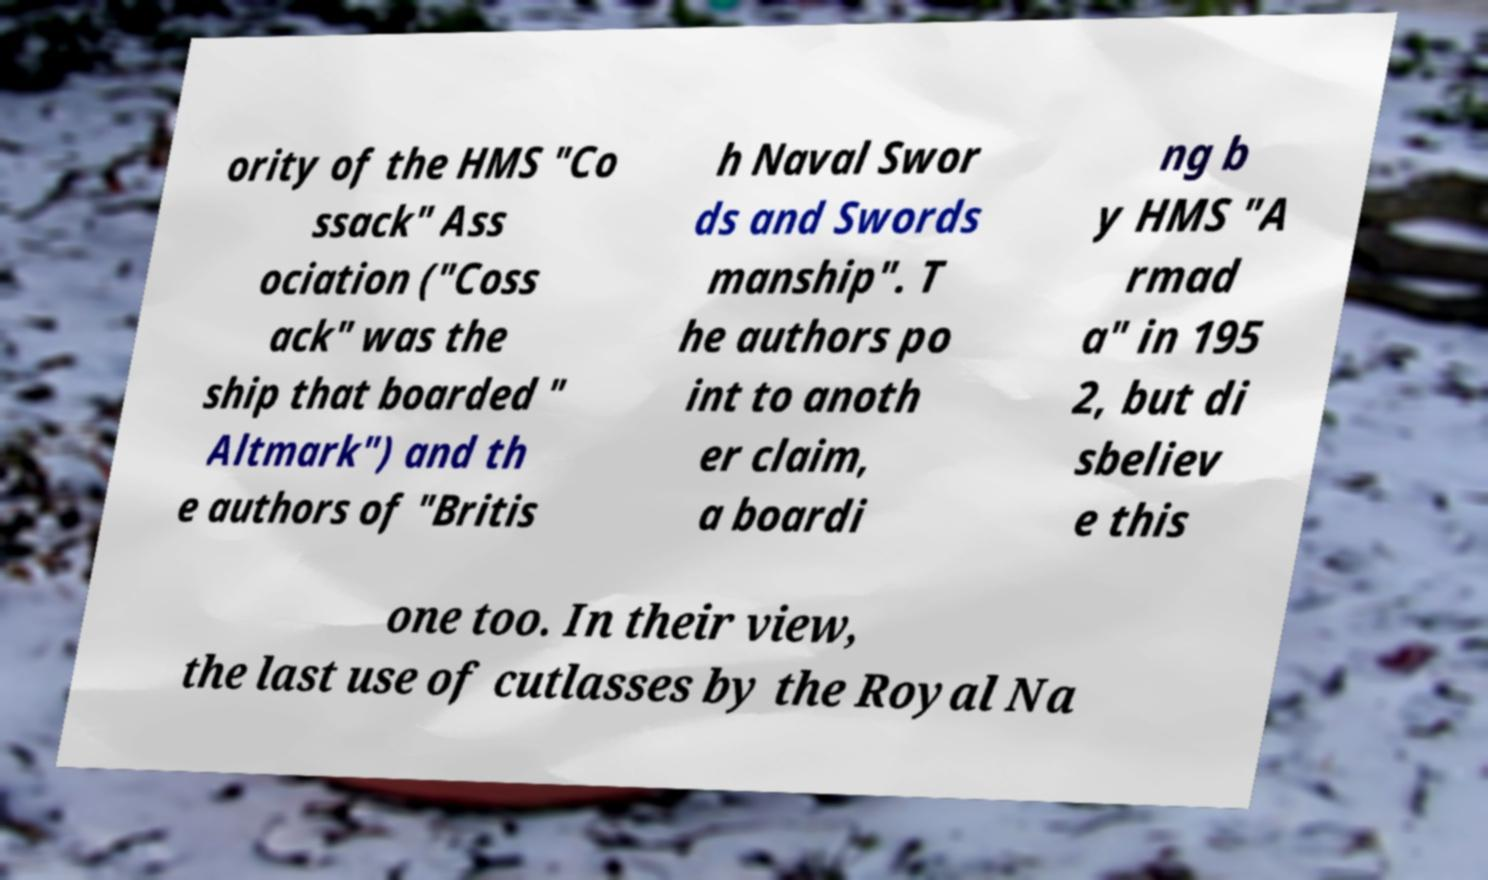Can you accurately transcribe the text from the provided image for me? ority of the HMS "Co ssack" Ass ociation ("Coss ack" was the ship that boarded " Altmark") and th e authors of "Britis h Naval Swor ds and Swords manship". T he authors po int to anoth er claim, a boardi ng b y HMS "A rmad a" in 195 2, but di sbeliev e this one too. In their view, the last use of cutlasses by the Royal Na 